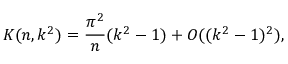Convert formula to latex. <formula><loc_0><loc_0><loc_500><loc_500>K ( n , k ^ { 2 } ) = \frac { \pi ^ { 2 } } { n } ( k ^ { 2 } - 1 ) + O ( ( k ^ { 2 } - 1 ) ^ { 2 } ) ,</formula> 